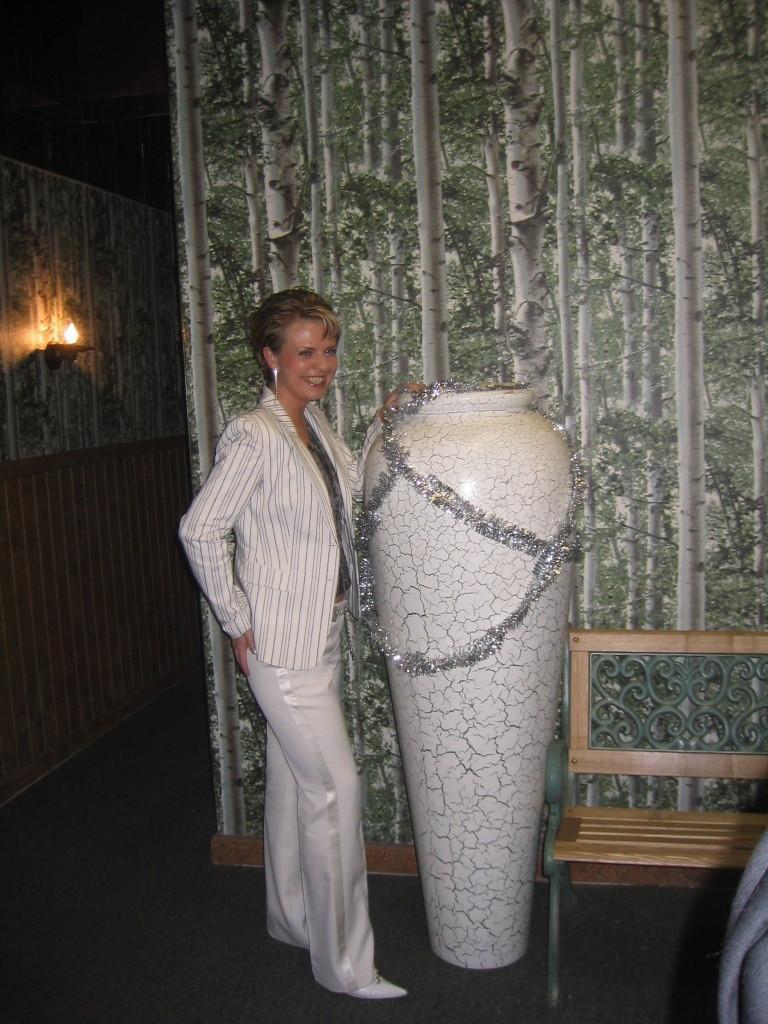Could you give a brief overview of what you see in this image? In this image I can see a woman standing and posing for the picture in the center of the image. I can see a wooden wall behind her, a vase beside her with some decorating, a wooden bench on the right hand side. I can see a lamp on the left hand side of the image with a dark background. 